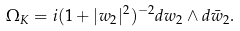Convert formula to latex. <formula><loc_0><loc_0><loc_500><loc_500>\Omega _ { K } = i ( 1 + | w _ { 2 } | ^ { 2 } ) ^ { - 2 } d w _ { 2 } \wedge d \bar { w } _ { 2 } .</formula> 